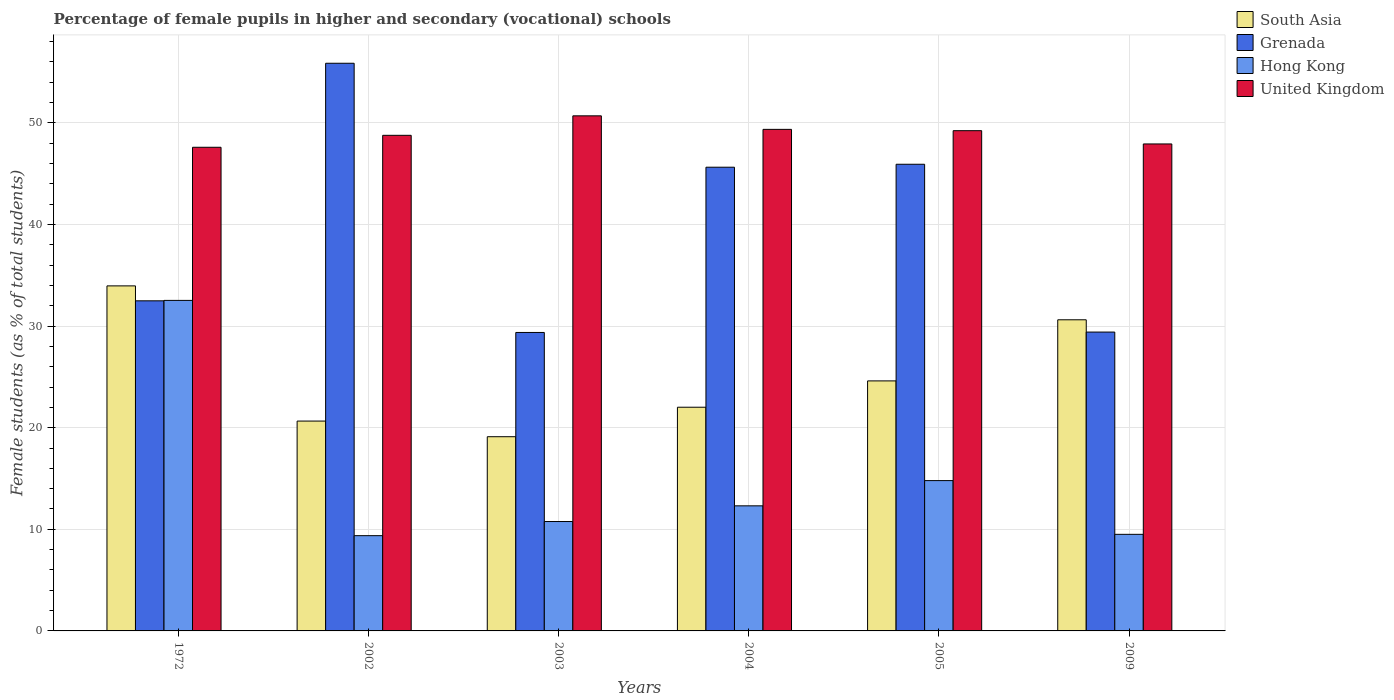Are the number of bars per tick equal to the number of legend labels?
Offer a terse response. Yes. How many bars are there on the 3rd tick from the left?
Provide a succinct answer. 4. How many bars are there on the 1st tick from the right?
Provide a short and direct response. 4. In how many cases, is the number of bars for a given year not equal to the number of legend labels?
Your answer should be very brief. 0. What is the percentage of female pupils in higher and secondary schools in South Asia in 2002?
Keep it short and to the point. 20.65. Across all years, what is the maximum percentage of female pupils in higher and secondary schools in Grenada?
Make the answer very short. 55.87. Across all years, what is the minimum percentage of female pupils in higher and secondary schools in United Kingdom?
Offer a very short reply. 47.6. In which year was the percentage of female pupils in higher and secondary schools in South Asia maximum?
Make the answer very short. 1972. What is the total percentage of female pupils in higher and secondary schools in Hong Kong in the graph?
Your response must be concise. 89.28. What is the difference between the percentage of female pupils in higher and secondary schools in Hong Kong in 2004 and that in 2009?
Provide a short and direct response. 2.8. What is the difference between the percentage of female pupils in higher and secondary schools in Grenada in 2003 and the percentage of female pupils in higher and secondary schools in United Kingdom in 2009?
Your answer should be very brief. -18.55. What is the average percentage of female pupils in higher and secondary schools in South Asia per year?
Make the answer very short. 25.16. In the year 1972, what is the difference between the percentage of female pupils in higher and secondary schools in United Kingdom and percentage of female pupils in higher and secondary schools in Grenada?
Your response must be concise. 15.11. What is the ratio of the percentage of female pupils in higher and secondary schools in Hong Kong in 2002 to that in 2004?
Your answer should be very brief. 0.76. Is the difference between the percentage of female pupils in higher and secondary schools in United Kingdom in 2004 and 2005 greater than the difference between the percentage of female pupils in higher and secondary schools in Grenada in 2004 and 2005?
Your answer should be very brief. Yes. What is the difference between the highest and the second highest percentage of female pupils in higher and secondary schools in Grenada?
Your response must be concise. 9.94. What is the difference between the highest and the lowest percentage of female pupils in higher and secondary schools in United Kingdom?
Your answer should be very brief. 3.09. In how many years, is the percentage of female pupils in higher and secondary schools in Hong Kong greater than the average percentage of female pupils in higher and secondary schools in Hong Kong taken over all years?
Provide a succinct answer. 1. Is the sum of the percentage of female pupils in higher and secondary schools in Hong Kong in 1972 and 2002 greater than the maximum percentage of female pupils in higher and secondary schools in South Asia across all years?
Your response must be concise. Yes. Is it the case that in every year, the sum of the percentage of female pupils in higher and secondary schools in Hong Kong and percentage of female pupils in higher and secondary schools in United Kingdom is greater than the sum of percentage of female pupils in higher and secondary schools in South Asia and percentage of female pupils in higher and secondary schools in Grenada?
Keep it short and to the point. No. What does the 2nd bar from the left in 2005 represents?
Give a very brief answer. Grenada. What does the 4th bar from the right in 2004 represents?
Your answer should be very brief. South Asia. Are all the bars in the graph horizontal?
Provide a short and direct response. No. What is the difference between two consecutive major ticks on the Y-axis?
Make the answer very short. 10. Are the values on the major ticks of Y-axis written in scientific E-notation?
Provide a short and direct response. No. Where does the legend appear in the graph?
Keep it short and to the point. Top right. How are the legend labels stacked?
Make the answer very short. Vertical. What is the title of the graph?
Offer a terse response. Percentage of female pupils in higher and secondary (vocational) schools. Does "Uganda" appear as one of the legend labels in the graph?
Your response must be concise. No. What is the label or title of the Y-axis?
Your response must be concise. Female students (as % of total students). What is the Female students (as % of total students) of South Asia in 1972?
Provide a succinct answer. 33.96. What is the Female students (as % of total students) of Grenada in 1972?
Offer a terse response. 32.49. What is the Female students (as % of total students) in Hong Kong in 1972?
Your response must be concise. 32.53. What is the Female students (as % of total students) of United Kingdom in 1972?
Make the answer very short. 47.6. What is the Female students (as % of total students) of South Asia in 2002?
Offer a terse response. 20.65. What is the Female students (as % of total students) in Grenada in 2002?
Make the answer very short. 55.87. What is the Female students (as % of total students) in Hong Kong in 2002?
Offer a terse response. 9.37. What is the Female students (as % of total students) in United Kingdom in 2002?
Your answer should be very brief. 48.77. What is the Female students (as % of total students) of South Asia in 2003?
Keep it short and to the point. 19.11. What is the Female students (as % of total students) in Grenada in 2003?
Give a very brief answer. 29.37. What is the Female students (as % of total students) in Hong Kong in 2003?
Provide a succinct answer. 10.77. What is the Female students (as % of total students) of United Kingdom in 2003?
Give a very brief answer. 50.69. What is the Female students (as % of total students) in South Asia in 2004?
Offer a terse response. 22.01. What is the Female students (as % of total students) of Grenada in 2004?
Make the answer very short. 45.63. What is the Female students (as % of total students) in Hong Kong in 2004?
Provide a succinct answer. 12.31. What is the Female students (as % of total students) in United Kingdom in 2004?
Give a very brief answer. 49.36. What is the Female students (as % of total students) of South Asia in 2005?
Your response must be concise. 24.6. What is the Female students (as % of total students) of Grenada in 2005?
Make the answer very short. 45.93. What is the Female students (as % of total students) in Hong Kong in 2005?
Your response must be concise. 14.79. What is the Female students (as % of total students) in United Kingdom in 2005?
Give a very brief answer. 49.23. What is the Female students (as % of total students) of South Asia in 2009?
Ensure brevity in your answer.  30.62. What is the Female students (as % of total students) of Grenada in 2009?
Give a very brief answer. 29.41. What is the Female students (as % of total students) of Hong Kong in 2009?
Your answer should be compact. 9.51. What is the Female students (as % of total students) in United Kingdom in 2009?
Your response must be concise. 47.92. Across all years, what is the maximum Female students (as % of total students) of South Asia?
Your response must be concise. 33.96. Across all years, what is the maximum Female students (as % of total students) in Grenada?
Ensure brevity in your answer.  55.87. Across all years, what is the maximum Female students (as % of total students) of Hong Kong?
Make the answer very short. 32.53. Across all years, what is the maximum Female students (as % of total students) in United Kingdom?
Keep it short and to the point. 50.69. Across all years, what is the minimum Female students (as % of total students) in South Asia?
Provide a succinct answer. 19.11. Across all years, what is the minimum Female students (as % of total students) of Grenada?
Make the answer very short. 29.37. Across all years, what is the minimum Female students (as % of total students) in Hong Kong?
Ensure brevity in your answer.  9.37. Across all years, what is the minimum Female students (as % of total students) in United Kingdom?
Keep it short and to the point. 47.6. What is the total Female students (as % of total students) in South Asia in the graph?
Provide a short and direct response. 150.96. What is the total Female students (as % of total students) of Grenada in the graph?
Provide a short and direct response. 238.7. What is the total Female students (as % of total students) of Hong Kong in the graph?
Provide a succinct answer. 89.28. What is the total Female students (as % of total students) in United Kingdom in the graph?
Provide a short and direct response. 293.58. What is the difference between the Female students (as % of total students) in South Asia in 1972 and that in 2002?
Your answer should be very brief. 13.3. What is the difference between the Female students (as % of total students) of Grenada in 1972 and that in 2002?
Your response must be concise. -23.38. What is the difference between the Female students (as % of total students) of Hong Kong in 1972 and that in 2002?
Make the answer very short. 23.15. What is the difference between the Female students (as % of total students) of United Kingdom in 1972 and that in 2002?
Give a very brief answer. -1.18. What is the difference between the Female students (as % of total students) of South Asia in 1972 and that in 2003?
Provide a short and direct response. 14.84. What is the difference between the Female students (as % of total students) of Grenada in 1972 and that in 2003?
Your answer should be very brief. 3.11. What is the difference between the Female students (as % of total students) in Hong Kong in 1972 and that in 2003?
Offer a terse response. 21.76. What is the difference between the Female students (as % of total students) in United Kingdom in 1972 and that in 2003?
Give a very brief answer. -3.09. What is the difference between the Female students (as % of total students) in South Asia in 1972 and that in 2004?
Give a very brief answer. 11.94. What is the difference between the Female students (as % of total students) of Grenada in 1972 and that in 2004?
Your response must be concise. -13.15. What is the difference between the Female students (as % of total students) of Hong Kong in 1972 and that in 2004?
Provide a succinct answer. 20.22. What is the difference between the Female students (as % of total students) of United Kingdom in 1972 and that in 2004?
Provide a succinct answer. -1.76. What is the difference between the Female students (as % of total students) of South Asia in 1972 and that in 2005?
Provide a short and direct response. 9.35. What is the difference between the Female students (as % of total students) of Grenada in 1972 and that in 2005?
Offer a very short reply. -13.44. What is the difference between the Female students (as % of total students) in Hong Kong in 1972 and that in 2005?
Ensure brevity in your answer.  17.73. What is the difference between the Female students (as % of total students) of United Kingdom in 1972 and that in 2005?
Make the answer very short. -1.63. What is the difference between the Female students (as % of total students) in South Asia in 1972 and that in 2009?
Offer a very short reply. 3.34. What is the difference between the Female students (as % of total students) in Grenada in 1972 and that in 2009?
Provide a succinct answer. 3.07. What is the difference between the Female students (as % of total students) in Hong Kong in 1972 and that in 2009?
Keep it short and to the point. 23.02. What is the difference between the Female students (as % of total students) of United Kingdom in 1972 and that in 2009?
Your answer should be compact. -0.33. What is the difference between the Female students (as % of total students) of South Asia in 2002 and that in 2003?
Provide a succinct answer. 1.54. What is the difference between the Female students (as % of total students) of Grenada in 2002 and that in 2003?
Your answer should be very brief. 26.49. What is the difference between the Female students (as % of total students) of Hong Kong in 2002 and that in 2003?
Provide a short and direct response. -1.39. What is the difference between the Female students (as % of total students) of United Kingdom in 2002 and that in 2003?
Offer a very short reply. -1.92. What is the difference between the Female students (as % of total students) of South Asia in 2002 and that in 2004?
Provide a succinct answer. -1.36. What is the difference between the Female students (as % of total students) of Grenada in 2002 and that in 2004?
Offer a terse response. 10.23. What is the difference between the Female students (as % of total students) of Hong Kong in 2002 and that in 2004?
Make the answer very short. -2.94. What is the difference between the Female students (as % of total students) of United Kingdom in 2002 and that in 2004?
Your answer should be very brief. -0.59. What is the difference between the Female students (as % of total students) of South Asia in 2002 and that in 2005?
Your answer should be very brief. -3.95. What is the difference between the Female students (as % of total students) of Grenada in 2002 and that in 2005?
Keep it short and to the point. 9.94. What is the difference between the Female students (as % of total students) of Hong Kong in 2002 and that in 2005?
Keep it short and to the point. -5.42. What is the difference between the Female students (as % of total students) in United Kingdom in 2002 and that in 2005?
Ensure brevity in your answer.  -0.46. What is the difference between the Female students (as % of total students) of South Asia in 2002 and that in 2009?
Offer a very short reply. -9.97. What is the difference between the Female students (as % of total students) of Grenada in 2002 and that in 2009?
Your answer should be very brief. 26.45. What is the difference between the Female students (as % of total students) of Hong Kong in 2002 and that in 2009?
Your answer should be compact. -0.13. What is the difference between the Female students (as % of total students) in United Kingdom in 2002 and that in 2009?
Give a very brief answer. 0.85. What is the difference between the Female students (as % of total students) in South Asia in 2003 and that in 2004?
Provide a succinct answer. -2.9. What is the difference between the Female students (as % of total students) of Grenada in 2003 and that in 2004?
Offer a terse response. -16.26. What is the difference between the Female students (as % of total students) in Hong Kong in 2003 and that in 2004?
Your answer should be very brief. -1.54. What is the difference between the Female students (as % of total students) of United Kingdom in 2003 and that in 2004?
Your answer should be very brief. 1.33. What is the difference between the Female students (as % of total students) of South Asia in 2003 and that in 2005?
Your answer should be compact. -5.49. What is the difference between the Female students (as % of total students) in Grenada in 2003 and that in 2005?
Your response must be concise. -16.55. What is the difference between the Female students (as % of total students) in Hong Kong in 2003 and that in 2005?
Offer a terse response. -4.03. What is the difference between the Female students (as % of total students) of United Kingdom in 2003 and that in 2005?
Your answer should be very brief. 1.46. What is the difference between the Female students (as % of total students) in South Asia in 2003 and that in 2009?
Your answer should be compact. -11.51. What is the difference between the Female students (as % of total students) in Grenada in 2003 and that in 2009?
Your answer should be compact. -0.04. What is the difference between the Female students (as % of total students) of Hong Kong in 2003 and that in 2009?
Your answer should be very brief. 1.26. What is the difference between the Female students (as % of total students) in United Kingdom in 2003 and that in 2009?
Keep it short and to the point. 2.77. What is the difference between the Female students (as % of total students) in South Asia in 2004 and that in 2005?
Your answer should be very brief. -2.59. What is the difference between the Female students (as % of total students) of Grenada in 2004 and that in 2005?
Provide a short and direct response. -0.29. What is the difference between the Female students (as % of total students) in Hong Kong in 2004 and that in 2005?
Give a very brief answer. -2.48. What is the difference between the Female students (as % of total students) of United Kingdom in 2004 and that in 2005?
Your answer should be compact. 0.13. What is the difference between the Female students (as % of total students) of South Asia in 2004 and that in 2009?
Make the answer very short. -8.61. What is the difference between the Female students (as % of total students) of Grenada in 2004 and that in 2009?
Give a very brief answer. 16.22. What is the difference between the Female students (as % of total students) in Hong Kong in 2004 and that in 2009?
Your answer should be compact. 2.8. What is the difference between the Female students (as % of total students) of United Kingdom in 2004 and that in 2009?
Provide a short and direct response. 1.44. What is the difference between the Female students (as % of total students) in South Asia in 2005 and that in 2009?
Make the answer very short. -6.02. What is the difference between the Female students (as % of total students) of Grenada in 2005 and that in 2009?
Provide a short and direct response. 16.51. What is the difference between the Female students (as % of total students) of Hong Kong in 2005 and that in 2009?
Give a very brief answer. 5.29. What is the difference between the Female students (as % of total students) in United Kingdom in 2005 and that in 2009?
Offer a very short reply. 1.31. What is the difference between the Female students (as % of total students) in South Asia in 1972 and the Female students (as % of total students) in Grenada in 2002?
Offer a very short reply. -21.91. What is the difference between the Female students (as % of total students) of South Asia in 1972 and the Female students (as % of total students) of Hong Kong in 2002?
Offer a terse response. 24.58. What is the difference between the Female students (as % of total students) in South Asia in 1972 and the Female students (as % of total students) in United Kingdom in 2002?
Offer a terse response. -14.82. What is the difference between the Female students (as % of total students) of Grenada in 1972 and the Female students (as % of total students) of Hong Kong in 2002?
Keep it short and to the point. 23.11. What is the difference between the Female students (as % of total students) in Grenada in 1972 and the Female students (as % of total students) in United Kingdom in 2002?
Provide a short and direct response. -16.29. What is the difference between the Female students (as % of total students) in Hong Kong in 1972 and the Female students (as % of total students) in United Kingdom in 2002?
Offer a terse response. -16.25. What is the difference between the Female students (as % of total students) in South Asia in 1972 and the Female students (as % of total students) in Grenada in 2003?
Offer a very short reply. 4.58. What is the difference between the Female students (as % of total students) in South Asia in 1972 and the Female students (as % of total students) in Hong Kong in 2003?
Your answer should be very brief. 23.19. What is the difference between the Female students (as % of total students) of South Asia in 1972 and the Female students (as % of total students) of United Kingdom in 2003?
Ensure brevity in your answer.  -16.73. What is the difference between the Female students (as % of total students) in Grenada in 1972 and the Female students (as % of total students) in Hong Kong in 2003?
Provide a succinct answer. 21.72. What is the difference between the Female students (as % of total students) in Grenada in 1972 and the Female students (as % of total students) in United Kingdom in 2003?
Offer a terse response. -18.21. What is the difference between the Female students (as % of total students) in Hong Kong in 1972 and the Female students (as % of total students) in United Kingdom in 2003?
Your response must be concise. -18.16. What is the difference between the Female students (as % of total students) in South Asia in 1972 and the Female students (as % of total students) in Grenada in 2004?
Provide a short and direct response. -11.68. What is the difference between the Female students (as % of total students) of South Asia in 1972 and the Female students (as % of total students) of Hong Kong in 2004?
Ensure brevity in your answer.  21.65. What is the difference between the Female students (as % of total students) in South Asia in 1972 and the Female students (as % of total students) in United Kingdom in 2004?
Your answer should be compact. -15.4. What is the difference between the Female students (as % of total students) in Grenada in 1972 and the Female students (as % of total students) in Hong Kong in 2004?
Your answer should be very brief. 20.18. What is the difference between the Female students (as % of total students) in Grenada in 1972 and the Female students (as % of total students) in United Kingdom in 2004?
Ensure brevity in your answer.  -16.87. What is the difference between the Female students (as % of total students) in Hong Kong in 1972 and the Female students (as % of total students) in United Kingdom in 2004?
Keep it short and to the point. -16.83. What is the difference between the Female students (as % of total students) of South Asia in 1972 and the Female students (as % of total students) of Grenada in 2005?
Your answer should be compact. -11.97. What is the difference between the Female students (as % of total students) in South Asia in 1972 and the Female students (as % of total students) in Hong Kong in 2005?
Keep it short and to the point. 19.16. What is the difference between the Female students (as % of total students) of South Asia in 1972 and the Female students (as % of total students) of United Kingdom in 2005?
Provide a succinct answer. -15.27. What is the difference between the Female students (as % of total students) of Grenada in 1972 and the Female students (as % of total students) of Hong Kong in 2005?
Ensure brevity in your answer.  17.69. What is the difference between the Female students (as % of total students) in Grenada in 1972 and the Female students (as % of total students) in United Kingdom in 2005?
Ensure brevity in your answer.  -16.74. What is the difference between the Female students (as % of total students) of Hong Kong in 1972 and the Female students (as % of total students) of United Kingdom in 2005?
Provide a succinct answer. -16.7. What is the difference between the Female students (as % of total students) in South Asia in 1972 and the Female students (as % of total students) in Grenada in 2009?
Offer a terse response. 4.54. What is the difference between the Female students (as % of total students) in South Asia in 1972 and the Female students (as % of total students) in Hong Kong in 2009?
Your answer should be compact. 24.45. What is the difference between the Female students (as % of total students) of South Asia in 1972 and the Female students (as % of total students) of United Kingdom in 2009?
Your answer should be compact. -13.97. What is the difference between the Female students (as % of total students) in Grenada in 1972 and the Female students (as % of total students) in Hong Kong in 2009?
Your answer should be very brief. 22.98. What is the difference between the Female students (as % of total students) in Grenada in 1972 and the Female students (as % of total students) in United Kingdom in 2009?
Keep it short and to the point. -15.44. What is the difference between the Female students (as % of total students) in Hong Kong in 1972 and the Female students (as % of total students) in United Kingdom in 2009?
Give a very brief answer. -15.4. What is the difference between the Female students (as % of total students) in South Asia in 2002 and the Female students (as % of total students) in Grenada in 2003?
Ensure brevity in your answer.  -8.72. What is the difference between the Female students (as % of total students) in South Asia in 2002 and the Female students (as % of total students) in Hong Kong in 2003?
Provide a short and direct response. 9.89. What is the difference between the Female students (as % of total students) of South Asia in 2002 and the Female students (as % of total students) of United Kingdom in 2003?
Make the answer very short. -30.04. What is the difference between the Female students (as % of total students) of Grenada in 2002 and the Female students (as % of total students) of Hong Kong in 2003?
Your answer should be compact. 45.1. What is the difference between the Female students (as % of total students) of Grenada in 2002 and the Female students (as % of total students) of United Kingdom in 2003?
Keep it short and to the point. 5.17. What is the difference between the Female students (as % of total students) of Hong Kong in 2002 and the Female students (as % of total students) of United Kingdom in 2003?
Provide a short and direct response. -41.32. What is the difference between the Female students (as % of total students) in South Asia in 2002 and the Female students (as % of total students) in Grenada in 2004?
Keep it short and to the point. -24.98. What is the difference between the Female students (as % of total students) of South Asia in 2002 and the Female students (as % of total students) of Hong Kong in 2004?
Provide a succinct answer. 8.34. What is the difference between the Female students (as % of total students) of South Asia in 2002 and the Female students (as % of total students) of United Kingdom in 2004?
Your answer should be very brief. -28.71. What is the difference between the Female students (as % of total students) in Grenada in 2002 and the Female students (as % of total students) in Hong Kong in 2004?
Offer a terse response. 43.56. What is the difference between the Female students (as % of total students) in Grenada in 2002 and the Female students (as % of total students) in United Kingdom in 2004?
Keep it short and to the point. 6.51. What is the difference between the Female students (as % of total students) of Hong Kong in 2002 and the Female students (as % of total students) of United Kingdom in 2004?
Provide a short and direct response. -39.99. What is the difference between the Female students (as % of total students) in South Asia in 2002 and the Female students (as % of total students) in Grenada in 2005?
Your answer should be very brief. -25.27. What is the difference between the Female students (as % of total students) of South Asia in 2002 and the Female students (as % of total students) of Hong Kong in 2005?
Make the answer very short. 5.86. What is the difference between the Female students (as % of total students) in South Asia in 2002 and the Female students (as % of total students) in United Kingdom in 2005?
Provide a succinct answer. -28.58. What is the difference between the Female students (as % of total students) in Grenada in 2002 and the Female students (as % of total students) in Hong Kong in 2005?
Offer a terse response. 41.07. What is the difference between the Female students (as % of total students) in Grenada in 2002 and the Female students (as % of total students) in United Kingdom in 2005?
Offer a very short reply. 6.64. What is the difference between the Female students (as % of total students) in Hong Kong in 2002 and the Female students (as % of total students) in United Kingdom in 2005?
Provide a short and direct response. -39.86. What is the difference between the Female students (as % of total students) of South Asia in 2002 and the Female students (as % of total students) of Grenada in 2009?
Offer a terse response. -8.76. What is the difference between the Female students (as % of total students) of South Asia in 2002 and the Female students (as % of total students) of Hong Kong in 2009?
Your answer should be very brief. 11.15. What is the difference between the Female students (as % of total students) of South Asia in 2002 and the Female students (as % of total students) of United Kingdom in 2009?
Provide a succinct answer. -27.27. What is the difference between the Female students (as % of total students) of Grenada in 2002 and the Female students (as % of total students) of Hong Kong in 2009?
Ensure brevity in your answer.  46.36. What is the difference between the Female students (as % of total students) of Grenada in 2002 and the Female students (as % of total students) of United Kingdom in 2009?
Your response must be concise. 7.94. What is the difference between the Female students (as % of total students) of Hong Kong in 2002 and the Female students (as % of total students) of United Kingdom in 2009?
Provide a succinct answer. -38.55. What is the difference between the Female students (as % of total students) of South Asia in 2003 and the Female students (as % of total students) of Grenada in 2004?
Keep it short and to the point. -26.52. What is the difference between the Female students (as % of total students) of South Asia in 2003 and the Female students (as % of total students) of Hong Kong in 2004?
Your response must be concise. 6.8. What is the difference between the Female students (as % of total students) in South Asia in 2003 and the Female students (as % of total students) in United Kingdom in 2004?
Give a very brief answer. -30.25. What is the difference between the Female students (as % of total students) in Grenada in 2003 and the Female students (as % of total students) in Hong Kong in 2004?
Your response must be concise. 17.06. What is the difference between the Female students (as % of total students) of Grenada in 2003 and the Female students (as % of total students) of United Kingdom in 2004?
Make the answer very short. -19.99. What is the difference between the Female students (as % of total students) of Hong Kong in 2003 and the Female students (as % of total students) of United Kingdom in 2004?
Your answer should be compact. -38.59. What is the difference between the Female students (as % of total students) of South Asia in 2003 and the Female students (as % of total students) of Grenada in 2005?
Provide a short and direct response. -26.81. What is the difference between the Female students (as % of total students) of South Asia in 2003 and the Female students (as % of total students) of Hong Kong in 2005?
Give a very brief answer. 4.32. What is the difference between the Female students (as % of total students) in South Asia in 2003 and the Female students (as % of total students) in United Kingdom in 2005?
Your answer should be compact. -30.12. What is the difference between the Female students (as % of total students) in Grenada in 2003 and the Female students (as % of total students) in Hong Kong in 2005?
Your answer should be compact. 14.58. What is the difference between the Female students (as % of total students) of Grenada in 2003 and the Female students (as % of total students) of United Kingdom in 2005?
Provide a short and direct response. -19.86. What is the difference between the Female students (as % of total students) of Hong Kong in 2003 and the Female students (as % of total students) of United Kingdom in 2005?
Your answer should be very brief. -38.46. What is the difference between the Female students (as % of total students) of South Asia in 2003 and the Female students (as % of total students) of Grenada in 2009?
Offer a terse response. -10.3. What is the difference between the Female students (as % of total students) of South Asia in 2003 and the Female students (as % of total students) of Hong Kong in 2009?
Give a very brief answer. 9.61. What is the difference between the Female students (as % of total students) in South Asia in 2003 and the Female students (as % of total students) in United Kingdom in 2009?
Your answer should be very brief. -28.81. What is the difference between the Female students (as % of total students) in Grenada in 2003 and the Female students (as % of total students) in Hong Kong in 2009?
Keep it short and to the point. 19.87. What is the difference between the Female students (as % of total students) in Grenada in 2003 and the Female students (as % of total students) in United Kingdom in 2009?
Your answer should be very brief. -18.55. What is the difference between the Female students (as % of total students) of Hong Kong in 2003 and the Female students (as % of total students) of United Kingdom in 2009?
Keep it short and to the point. -37.16. What is the difference between the Female students (as % of total students) in South Asia in 2004 and the Female students (as % of total students) in Grenada in 2005?
Offer a very short reply. -23.91. What is the difference between the Female students (as % of total students) in South Asia in 2004 and the Female students (as % of total students) in Hong Kong in 2005?
Provide a succinct answer. 7.22. What is the difference between the Female students (as % of total students) in South Asia in 2004 and the Female students (as % of total students) in United Kingdom in 2005?
Ensure brevity in your answer.  -27.22. What is the difference between the Female students (as % of total students) of Grenada in 2004 and the Female students (as % of total students) of Hong Kong in 2005?
Provide a succinct answer. 30.84. What is the difference between the Female students (as % of total students) of Grenada in 2004 and the Female students (as % of total students) of United Kingdom in 2005?
Your answer should be compact. -3.6. What is the difference between the Female students (as % of total students) of Hong Kong in 2004 and the Female students (as % of total students) of United Kingdom in 2005?
Give a very brief answer. -36.92. What is the difference between the Female students (as % of total students) in South Asia in 2004 and the Female students (as % of total students) in Grenada in 2009?
Keep it short and to the point. -7.4. What is the difference between the Female students (as % of total students) of South Asia in 2004 and the Female students (as % of total students) of Hong Kong in 2009?
Give a very brief answer. 12.51. What is the difference between the Female students (as % of total students) in South Asia in 2004 and the Female students (as % of total students) in United Kingdom in 2009?
Make the answer very short. -25.91. What is the difference between the Female students (as % of total students) of Grenada in 2004 and the Female students (as % of total students) of Hong Kong in 2009?
Your answer should be very brief. 36.13. What is the difference between the Female students (as % of total students) of Grenada in 2004 and the Female students (as % of total students) of United Kingdom in 2009?
Your response must be concise. -2.29. What is the difference between the Female students (as % of total students) in Hong Kong in 2004 and the Female students (as % of total students) in United Kingdom in 2009?
Your response must be concise. -35.61. What is the difference between the Female students (as % of total students) in South Asia in 2005 and the Female students (as % of total students) in Grenada in 2009?
Offer a terse response. -4.81. What is the difference between the Female students (as % of total students) of South Asia in 2005 and the Female students (as % of total students) of Hong Kong in 2009?
Make the answer very short. 15.1. What is the difference between the Female students (as % of total students) in South Asia in 2005 and the Female students (as % of total students) in United Kingdom in 2009?
Your answer should be compact. -23.32. What is the difference between the Female students (as % of total students) of Grenada in 2005 and the Female students (as % of total students) of Hong Kong in 2009?
Provide a succinct answer. 36.42. What is the difference between the Female students (as % of total students) in Grenada in 2005 and the Female students (as % of total students) in United Kingdom in 2009?
Provide a succinct answer. -2. What is the difference between the Female students (as % of total students) of Hong Kong in 2005 and the Female students (as % of total students) of United Kingdom in 2009?
Provide a short and direct response. -33.13. What is the average Female students (as % of total students) in South Asia per year?
Your answer should be compact. 25.16. What is the average Female students (as % of total students) in Grenada per year?
Give a very brief answer. 39.78. What is the average Female students (as % of total students) in Hong Kong per year?
Provide a short and direct response. 14.88. What is the average Female students (as % of total students) in United Kingdom per year?
Give a very brief answer. 48.93. In the year 1972, what is the difference between the Female students (as % of total students) of South Asia and Female students (as % of total students) of Grenada?
Provide a short and direct response. 1.47. In the year 1972, what is the difference between the Female students (as % of total students) of South Asia and Female students (as % of total students) of Hong Kong?
Provide a succinct answer. 1.43. In the year 1972, what is the difference between the Female students (as % of total students) in South Asia and Female students (as % of total students) in United Kingdom?
Your answer should be compact. -13.64. In the year 1972, what is the difference between the Female students (as % of total students) of Grenada and Female students (as % of total students) of Hong Kong?
Provide a succinct answer. -0.04. In the year 1972, what is the difference between the Female students (as % of total students) of Grenada and Female students (as % of total students) of United Kingdom?
Provide a short and direct response. -15.11. In the year 1972, what is the difference between the Female students (as % of total students) of Hong Kong and Female students (as % of total students) of United Kingdom?
Offer a very short reply. -15.07. In the year 2002, what is the difference between the Female students (as % of total students) in South Asia and Female students (as % of total students) in Grenada?
Ensure brevity in your answer.  -35.21. In the year 2002, what is the difference between the Female students (as % of total students) of South Asia and Female students (as % of total students) of Hong Kong?
Keep it short and to the point. 11.28. In the year 2002, what is the difference between the Female students (as % of total students) of South Asia and Female students (as % of total students) of United Kingdom?
Your answer should be very brief. -28.12. In the year 2002, what is the difference between the Female students (as % of total students) in Grenada and Female students (as % of total students) in Hong Kong?
Make the answer very short. 46.49. In the year 2002, what is the difference between the Female students (as % of total students) in Grenada and Female students (as % of total students) in United Kingdom?
Ensure brevity in your answer.  7.09. In the year 2002, what is the difference between the Female students (as % of total students) in Hong Kong and Female students (as % of total students) in United Kingdom?
Provide a short and direct response. -39.4. In the year 2003, what is the difference between the Female students (as % of total students) in South Asia and Female students (as % of total students) in Grenada?
Provide a succinct answer. -10.26. In the year 2003, what is the difference between the Female students (as % of total students) of South Asia and Female students (as % of total students) of Hong Kong?
Keep it short and to the point. 8.35. In the year 2003, what is the difference between the Female students (as % of total students) of South Asia and Female students (as % of total students) of United Kingdom?
Offer a very short reply. -31.58. In the year 2003, what is the difference between the Female students (as % of total students) of Grenada and Female students (as % of total students) of Hong Kong?
Your response must be concise. 18.61. In the year 2003, what is the difference between the Female students (as % of total students) in Grenada and Female students (as % of total students) in United Kingdom?
Provide a succinct answer. -21.32. In the year 2003, what is the difference between the Female students (as % of total students) in Hong Kong and Female students (as % of total students) in United Kingdom?
Your response must be concise. -39.92. In the year 2004, what is the difference between the Female students (as % of total students) of South Asia and Female students (as % of total students) of Grenada?
Your response must be concise. -23.62. In the year 2004, what is the difference between the Female students (as % of total students) of South Asia and Female students (as % of total students) of Hong Kong?
Provide a short and direct response. 9.7. In the year 2004, what is the difference between the Female students (as % of total students) of South Asia and Female students (as % of total students) of United Kingdom?
Your answer should be compact. -27.35. In the year 2004, what is the difference between the Female students (as % of total students) in Grenada and Female students (as % of total students) in Hong Kong?
Provide a short and direct response. 33.32. In the year 2004, what is the difference between the Female students (as % of total students) of Grenada and Female students (as % of total students) of United Kingdom?
Your response must be concise. -3.72. In the year 2004, what is the difference between the Female students (as % of total students) in Hong Kong and Female students (as % of total students) in United Kingdom?
Ensure brevity in your answer.  -37.05. In the year 2005, what is the difference between the Female students (as % of total students) of South Asia and Female students (as % of total students) of Grenada?
Offer a terse response. -21.32. In the year 2005, what is the difference between the Female students (as % of total students) in South Asia and Female students (as % of total students) in Hong Kong?
Your response must be concise. 9.81. In the year 2005, what is the difference between the Female students (as % of total students) in South Asia and Female students (as % of total students) in United Kingdom?
Provide a succinct answer. -24.63. In the year 2005, what is the difference between the Female students (as % of total students) in Grenada and Female students (as % of total students) in Hong Kong?
Provide a short and direct response. 31.13. In the year 2005, what is the difference between the Female students (as % of total students) of Grenada and Female students (as % of total students) of United Kingdom?
Ensure brevity in your answer.  -3.3. In the year 2005, what is the difference between the Female students (as % of total students) in Hong Kong and Female students (as % of total students) in United Kingdom?
Ensure brevity in your answer.  -34.44. In the year 2009, what is the difference between the Female students (as % of total students) of South Asia and Female students (as % of total students) of Grenada?
Give a very brief answer. 1.21. In the year 2009, what is the difference between the Female students (as % of total students) of South Asia and Female students (as % of total students) of Hong Kong?
Provide a short and direct response. 21.11. In the year 2009, what is the difference between the Female students (as % of total students) in South Asia and Female students (as % of total students) in United Kingdom?
Provide a short and direct response. -17.3. In the year 2009, what is the difference between the Female students (as % of total students) in Grenada and Female students (as % of total students) in Hong Kong?
Give a very brief answer. 19.91. In the year 2009, what is the difference between the Female students (as % of total students) in Grenada and Female students (as % of total students) in United Kingdom?
Offer a terse response. -18.51. In the year 2009, what is the difference between the Female students (as % of total students) of Hong Kong and Female students (as % of total students) of United Kingdom?
Your answer should be compact. -38.42. What is the ratio of the Female students (as % of total students) in South Asia in 1972 to that in 2002?
Give a very brief answer. 1.64. What is the ratio of the Female students (as % of total students) of Grenada in 1972 to that in 2002?
Provide a succinct answer. 0.58. What is the ratio of the Female students (as % of total students) in Hong Kong in 1972 to that in 2002?
Offer a very short reply. 3.47. What is the ratio of the Female students (as % of total students) in United Kingdom in 1972 to that in 2002?
Give a very brief answer. 0.98. What is the ratio of the Female students (as % of total students) in South Asia in 1972 to that in 2003?
Make the answer very short. 1.78. What is the ratio of the Female students (as % of total students) in Grenada in 1972 to that in 2003?
Your response must be concise. 1.11. What is the ratio of the Female students (as % of total students) in Hong Kong in 1972 to that in 2003?
Make the answer very short. 3.02. What is the ratio of the Female students (as % of total students) in United Kingdom in 1972 to that in 2003?
Make the answer very short. 0.94. What is the ratio of the Female students (as % of total students) in South Asia in 1972 to that in 2004?
Your answer should be very brief. 1.54. What is the ratio of the Female students (as % of total students) in Grenada in 1972 to that in 2004?
Your response must be concise. 0.71. What is the ratio of the Female students (as % of total students) in Hong Kong in 1972 to that in 2004?
Keep it short and to the point. 2.64. What is the ratio of the Female students (as % of total students) in South Asia in 1972 to that in 2005?
Ensure brevity in your answer.  1.38. What is the ratio of the Female students (as % of total students) in Grenada in 1972 to that in 2005?
Offer a very short reply. 0.71. What is the ratio of the Female students (as % of total students) in Hong Kong in 1972 to that in 2005?
Provide a succinct answer. 2.2. What is the ratio of the Female students (as % of total students) of United Kingdom in 1972 to that in 2005?
Make the answer very short. 0.97. What is the ratio of the Female students (as % of total students) of South Asia in 1972 to that in 2009?
Offer a terse response. 1.11. What is the ratio of the Female students (as % of total students) of Grenada in 1972 to that in 2009?
Your answer should be compact. 1.1. What is the ratio of the Female students (as % of total students) in Hong Kong in 1972 to that in 2009?
Provide a succinct answer. 3.42. What is the ratio of the Female students (as % of total students) in South Asia in 2002 to that in 2003?
Make the answer very short. 1.08. What is the ratio of the Female students (as % of total students) of Grenada in 2002 to that in 2003?
Ensure brevity in your answer.  1.9. What is the ratio of the Female students (as % of total students) of Hong Kong in 2002 to that in 2003?
Your answer should be compact. 0.87. What is the ratio of the Female students (as % of total students) in United Kingdom in 2002 to that in 2003?
Your response must be concise. 0.96. What is the ratio of the Female students (as % of total students) in South Asia in 2002 to that in 2004?
Offer a very short reply. 0.94. What is the ratio of the Female students (as % of total students) of Grenada in 2002 to that in 2004?
Give a very brief answer. 1.22. What is the ratio of the Female students (as % of total students) in Hong Kong in 2002 to that in 2004?
Ensure brevity in your answer.  0.76. What is the ratio of the Female students (as % of total students) of South Asia in 2002 to that in 2005?
Your answer should be very brief. 0.84. What is the ratio of the Female students (as % of total students) of Grenada in 2002 to that in 2005?
Your answer should be compact. 1.22. What is the ratio of the Female students (as % of total students) in Hong Kong in 2002 to that in 2005?
Offer a very short reply. 0.63. What is the ratio of the Female students (as % of total students) of South Asia in 2002 to that in 2009?
Your response must be concise. 0.67. What is the ratio of the Female students (as % of total students) of Grenada in 2002 to that in 2009?
Keep it short and to the point. 1.9. What is the ratio of the Female students (as % of total students) of Hong Kong in 2002 to that in 2009?
Make the answer very short. 0.99. What is the ratio of the Female students (as % of total students) of United Kingdom in 2002 to that in 2009?
Your answer should be very brief. 1.02. What is the ratio of the Female students (as % of total students) of South Asia in 2003 to that in 2004?
Give a very brief answer. 0.87. What is the ratio of the Female students (as % of total students) of Grenada in 2003 to that in 2004?
Your answer should be very brief. 0.64. What is the ratio of the Female students (as % of total students) in Hong Kong in 2003 to that in 2004?
Provide a short and direct response. 0.87. What is the ratio of the Female students (as % of total students) of South Asia in 2003 to that in 2005?
Offer a terse response. 0.78. What is the ratio of the Female students (as % of total students) in Grenada in 2003 to that in 2005?
Provide a succinct answer. 0.64. What is the ratio of the Female students (as % of total students) of Hong Kong in 2003 to that in 2005?
Offer a terse response. 0.73. What is the ratio of the Female students (as % of total students) of United Kingdom in 2003 to that in 2005?
Your answer should be compact. 1.03. What is the ratio of the Female students (as % of total students) in South Asia in 2003 to that in 2009?
Make the answer very short. 0.62. What is the ratio of the Female students (as % of total students) in Grenada in 2003 to that in 2009?
Your answer should be very brief. 1. What is the ratio of the Female students (as % of total students) of Hong Kong in 2003 to that in 2009?
Provide a short and direct response. 1.13. What is the ratio of the Female students (as % of total students) in United Kingdom in 2003 to that in 2009?
Your response must be concise. 1.06. What is the ratio of the Female students (as % of total students) of South Asia in 2004 to that in 2005?
Ensure brevity in your answer.  0.89. What is the ratio of the Female students (as % of total students) in Grenada in 2004 to that in 2005?
Provide a succinct answer. 0.99. What is the ratio of the Female students (as % of total students) in Hong Kong in 2004 to that in 2005?
Provide a short and direct response. 0.83. What is the ratio of the Female students (as % of total students) in United Kingdom in 2004 to that in 2005?
Keep it short and to the point. 1. What is the ratio of the Female students (as % of total students) of South Asia in 2004 to that in 2009?
Keep it short and to the point. 0.72. What is the ratio of the Female students (as % of total students) in Grenada in 2004 to that in 2009?
Offer a very short reply. 1.55. What is the ratio of the Female students (as % of total students) of Hong Kong in 2004 to that in 2009?
Provide a succinct answer. 1.29. What is the ratio of the Female students (as % of total students) of United Kingdom in 2004 to that in 2009?
Provide a short and direct response. 1.03. What is the ratio of the Female students (as % of total students) of South Asia in 2005 to that in 2009?
Your response must be concise. 0.8. What is the ratio of the Female students (as % of total students) of Grenada in 2005 to that in 2009?
Offer a terse response. 1.56. What is the ratio of the Female students (as % of total students) of Hong Kong in 2005 to that in 2009?
Provide a succinct answer. 1.56. What is the ratio of the Female students (as % of total students) in United Kingdom in 2005 to that in 2009?
Make the answer very short. 1.03. What is the difference between the highest and the second highest Female students (as % of total students) of South Asia?
Offer a very short reply. 3.34. What is the difference between the highest and the second highest Female students (as % of total students) in Grenada?
Your answer should be very brief. 9.94. What is the difference between the highest and the second highest Female students (as % of total students) of Hong Kong?
Provide a short and direct response. 17.73. What is the difference between the highest and the second highest Female students (as % of total students) in United Kingdom?
Provide a succinct answer. 1.33. What is the difference between the highest and the lowest Female students (as % of total students) of South Asia?
Ensure brevity in your answer.  14.84. What is the difference between the highest and the lowest Female students (as % of total students) in Grenada?
Your response must be concise. 26.49. What is the difference between the highest and the lowest Female students (as % of total students) of Hong Kong?
Offer a terse response. 23.15. What is the difference between the highest and the lowest Female students (as % of total students) in United Kingdom?
Your response must be concise. 3.09. 